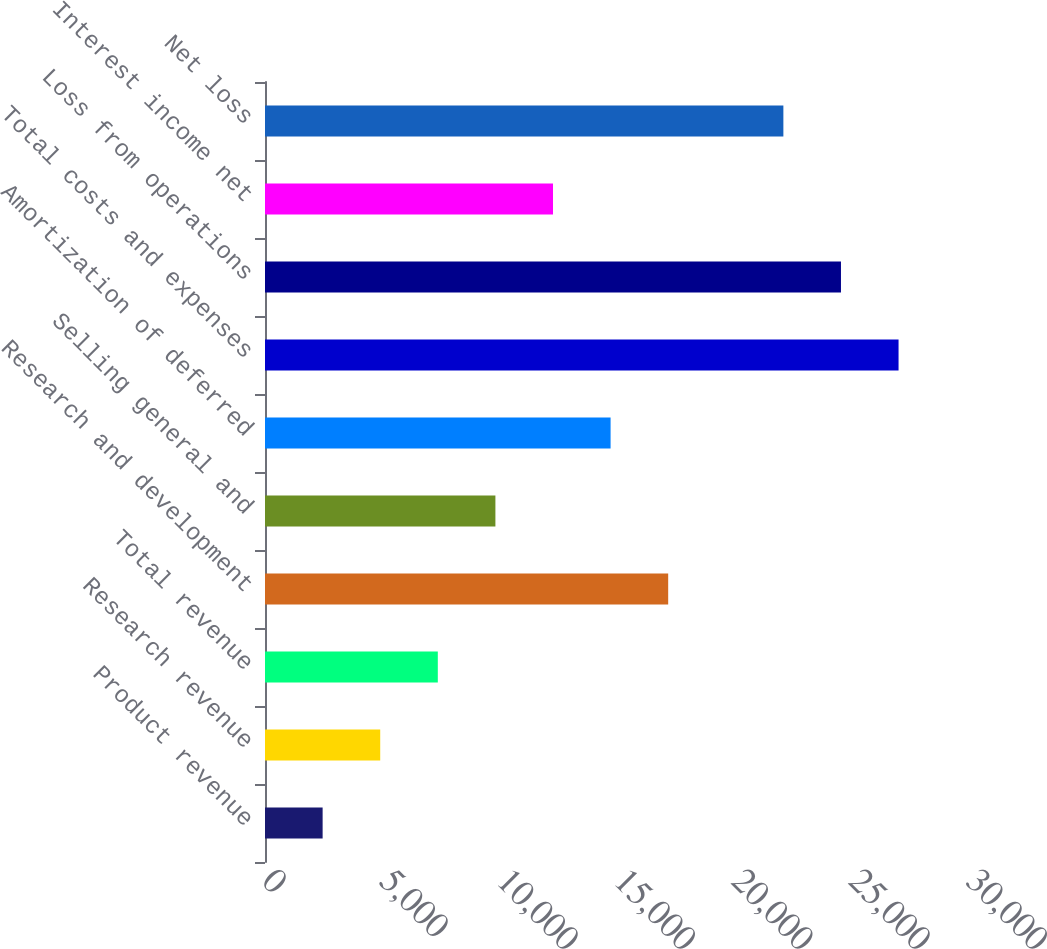Convert chart. <chart><loc_0><loc_0><loc_500><loc_500><bar_chart><fcel>Product revenue<fcel>Research revenue<fcel>Total revenue<fcel>Research and development<fcel>Selling general and<fcel>Amortization of deferred<fcel>Total costs and expenses<fcel>Loss from operations<fcel>Interest income net<fcel>Net loss<nl><fcel>2455.63<fcel>4909.89<fcel>7364.15<fcel>17181.2<fcel>9818.41<fcel>14726.9<fcel>26998.2<fcel>24544<fcel>12272.7<fcel>22089.7<nl></chart> 